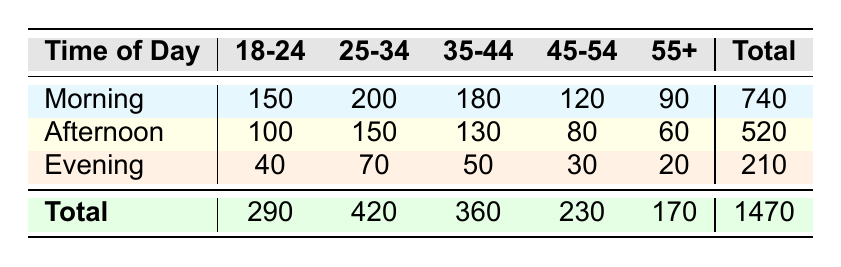What is the total coffee sales in the morning? The total sales in the morning can be found by looking at the "Total" column for the morning row, which indicates 740 sales.
Answer: 740 Which age group has the highest coffee sales in the afternoon? In the afternoon, the age group with the highest sales is the 25-34 age group, which has 150 sales, more than any other age group during that time.
Answer: 25-34 Is the total coffee sales for the evening greater than that of the afternoon? The total coffee sales for the evening is 210 and for the afternoon it is 520. Since 210 is less than 520, the statement is false.
Answer: No What is the average coffee sales for the age group 55+ across all time periods? The total coffee sales for the 55+ age group is 90 (morning) + 60 (afternoon) + 20 (evening) = 170. There are 3 time periods, therefore the average is 170/3, which is approximately 56.67.
Answer: 56.67 Which time of day has the lowest total sales? The lowest total sales can be found by comparing the totals for morning (740), afternoon (520), and evening (210). Evening has the lowest total sales among them.
Answer: Evening What is the difference in coffee sales between the age groups 18-24 and 45-54 during the morning? The sales for 18-24 in the morning is 150, and for 45-54, it is 120. The difference is calculated as 150 - 120 = 30.
Answer: 30 Are there more sales in the morning than in both the afternoon and evening combined? The total sales for the morning is 740, while the combined total for the afternoon (520) and evening (210) is 730. Since 740 is greater than 730, the statement is true.
Answer: Yes Which age group has the lowest coffee sales overall? To find the age group with the lowest overall sales, we must sum the sales for each age group: 18-24: 290, 25-34: 420, 35-44: 360, 45-54: 230, and 55+: 170. The age group 55+ has the lowest total sales at 170.
Answer: 55+ 